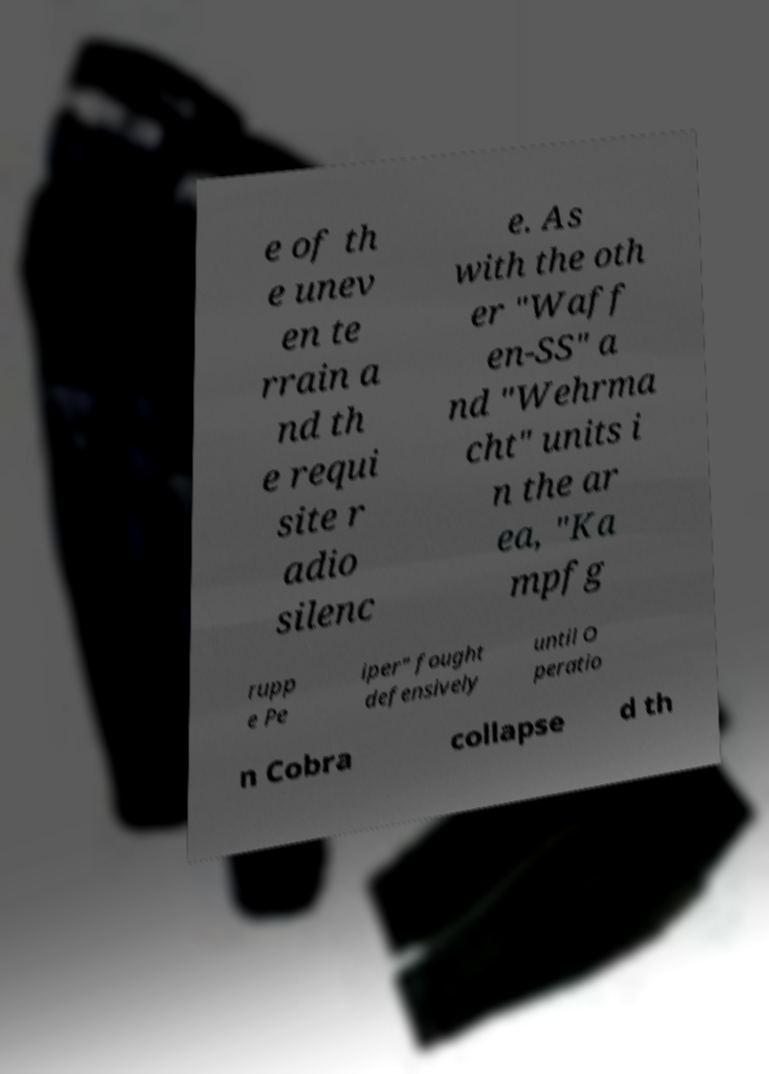Please read and relay the text visible in this image. What does it say? e of th e unev en te rrain a nd th e requi site r adio silenc e. As with the oth er "Waff en-SS" a nd "Wehrma cht" units i n the ar ea, "Ka mpfg rupp e Pe iper" fought defensively until O peratio n Cobra collapse d th 